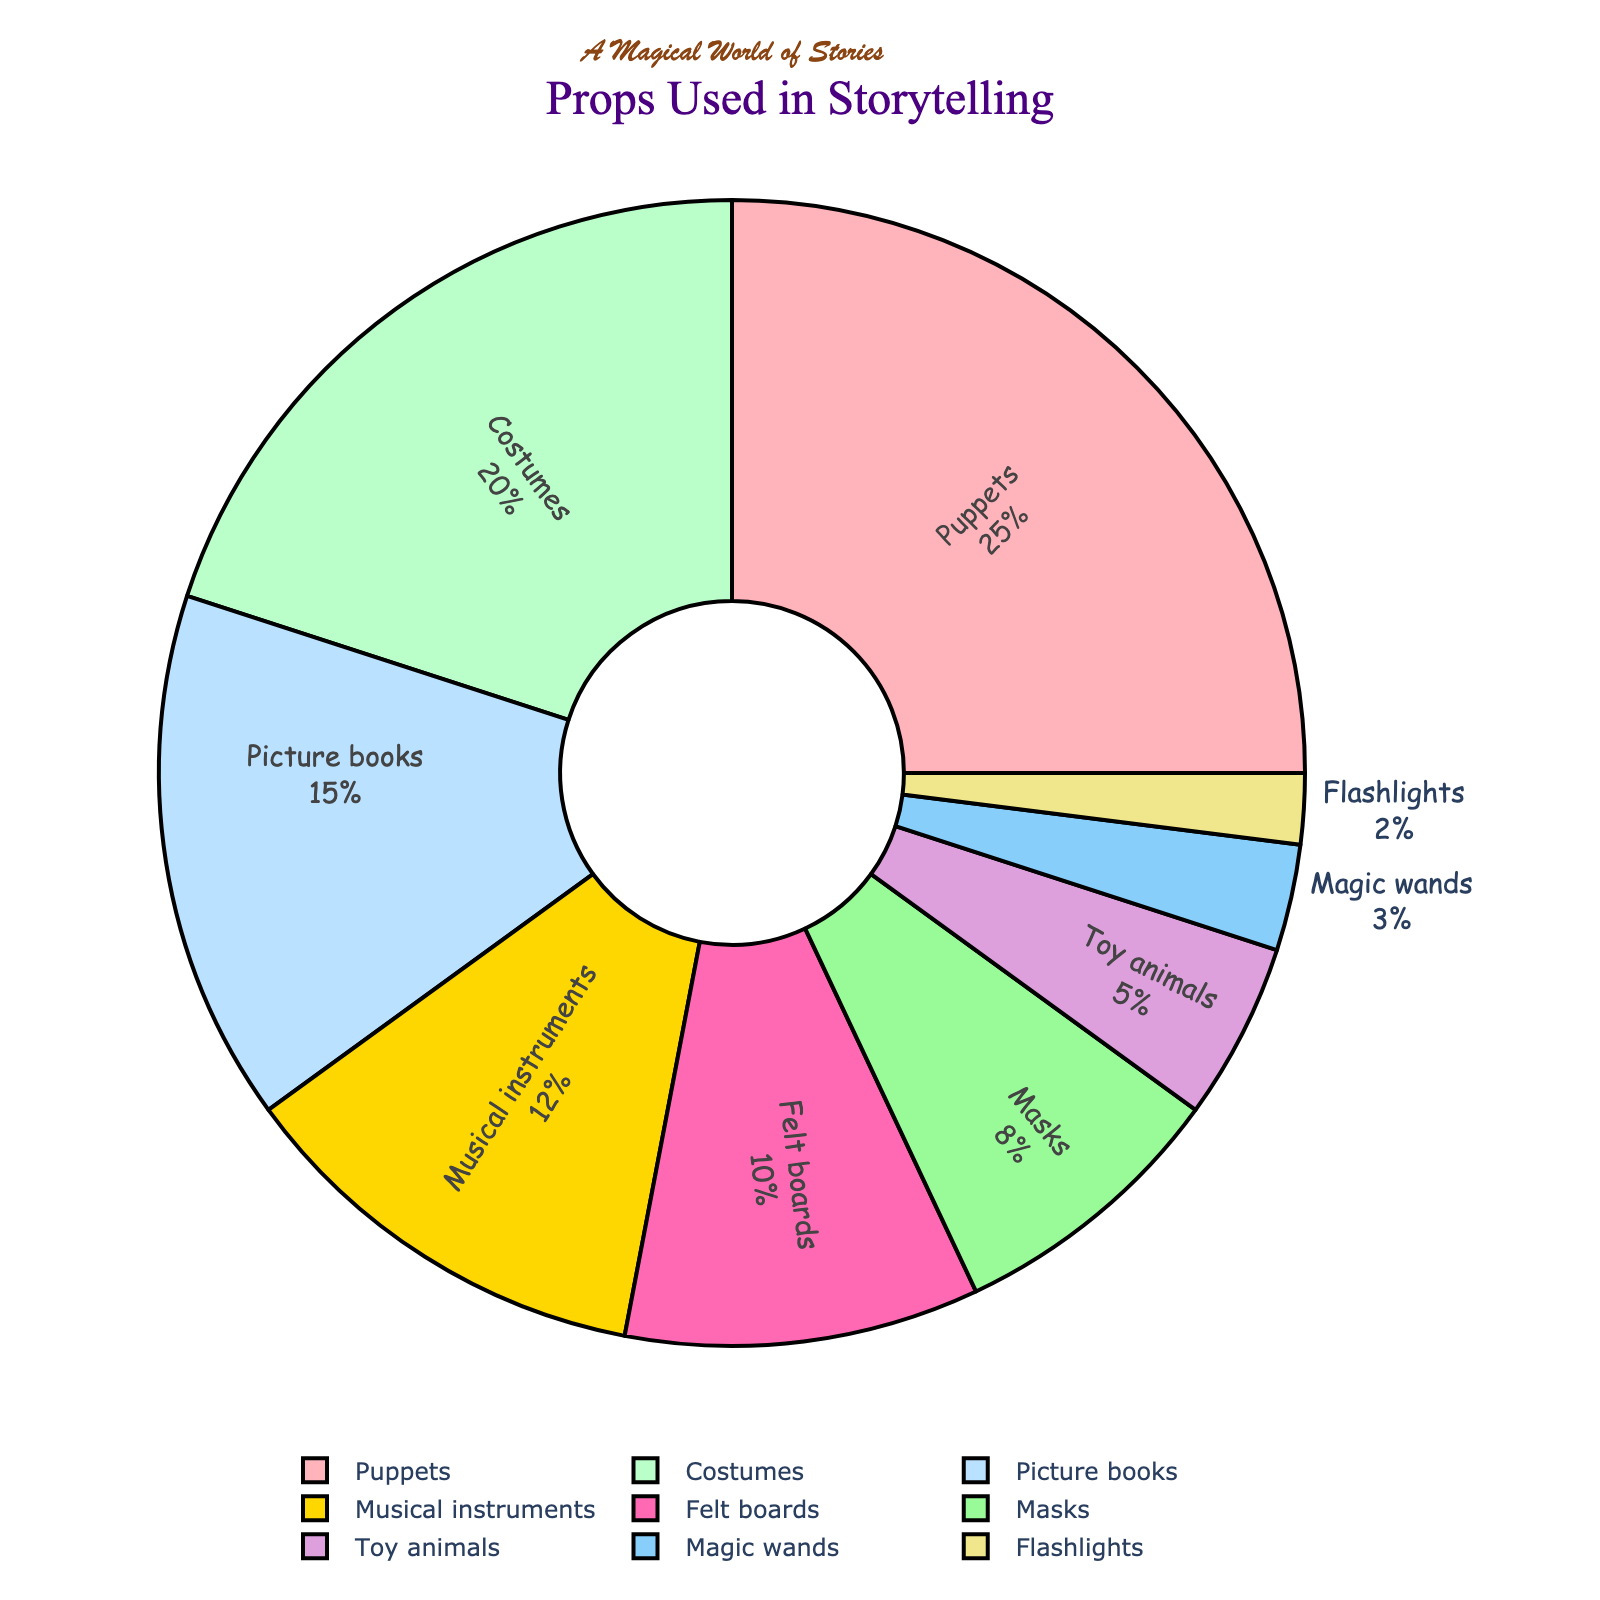Which prop is used the most during storytelling? According to the pie chart, puppets have the highest percentage amongst all the props used.
Answer: Puppets Which prop is used the least during storytelling? From the pie chart, flashlights have the smallest percentage, indicating they are used the least.
Answer: Flashlights What is the combined percentage of costumes and masks? Costumes have a percentage of 20% and masks have 8%. Adding 20% and 8% together gives 28%.
Answer: 28% Which props together make up more than half of the total percentage? Puppets (25%), costumes (20%), and picture books (15%) are the top three props. Adding their percentages: 25% + 20% + 15% = 60%, which is more than half of the total percentage.
Answer: Puppets, costumes, and picture books Does any single prop have a percentage greater than 30%? No, the highest percentage seen in the pie chart is 25%, which is for puppets.
Answer: No What is the difference in percentage between musical instruments and toy animals? Musical instruments have 12% and toy animals have 5%. The difference is calculated as 12% - 5% = 7%.
Answer: 7% Which two props together roughly equal the percentage of puppets? Costumes (20%) and flashlights (2%) together make 22%, which is close to 25% but not exactly equal. Costumes (20%) and toy animals (5%) together make 25%, which is exactly equal to the percentage of puppets.
Answer: Costumes and toy animals How much more popular are felt boards compared to flashlights? Felt boards have 10% while flashlights have 2%. The difference is 10% - 2% = 8%.
Answer: 8% Which prop has the second highest usage percentage? The second highest percentage is 20%, which corresponds to costumes in the pie chart.
Answer: Costumes 